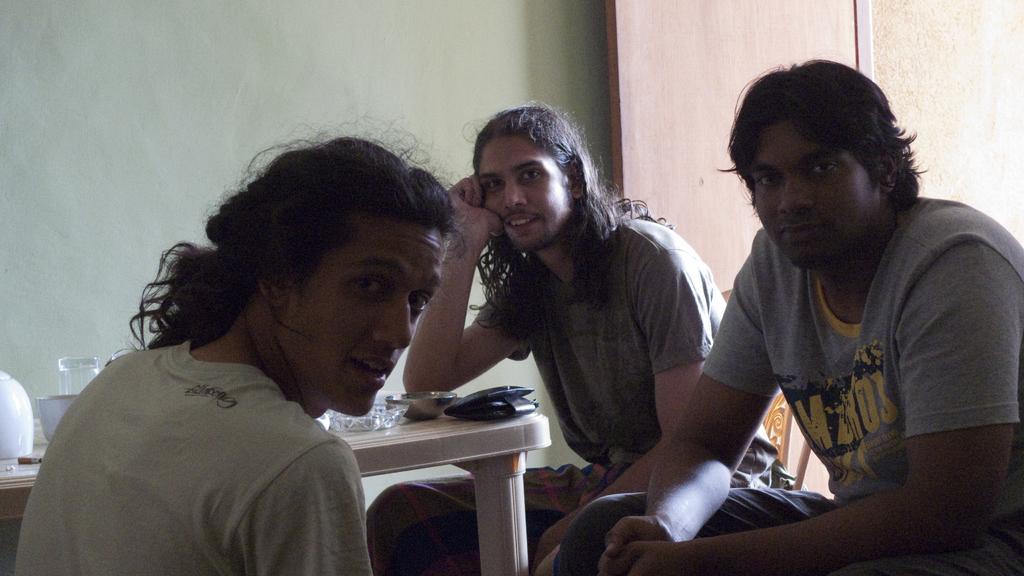Describe this image in one or two sentences. This 3 persons are sitting on a chair, in-front of this person there is a table, on a table there is a wallet, bowl, glass and cigar. 